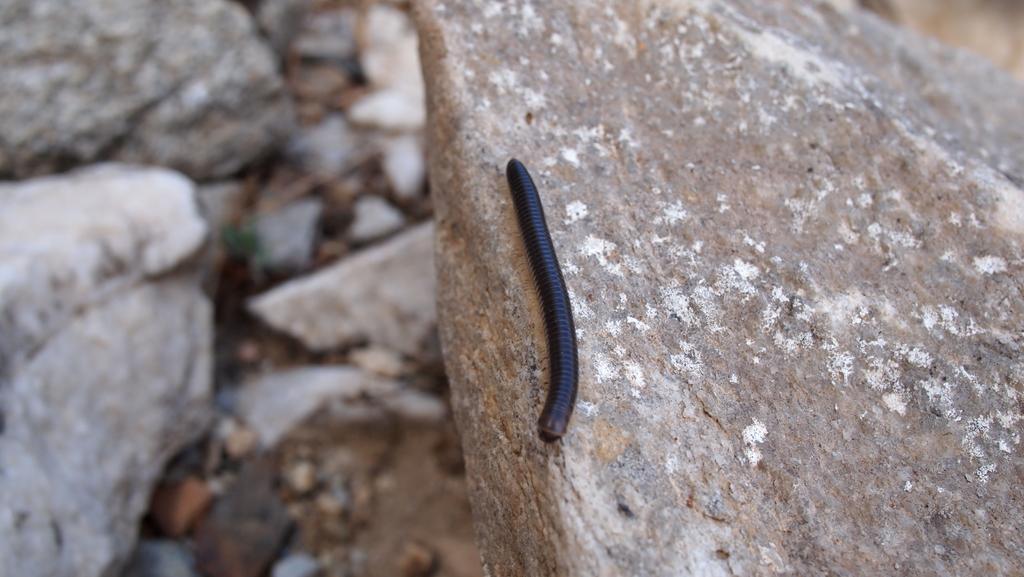Describe this image in one or two sentences. In this image there is an insect on the rock. To the left there are rocks on the ground. 